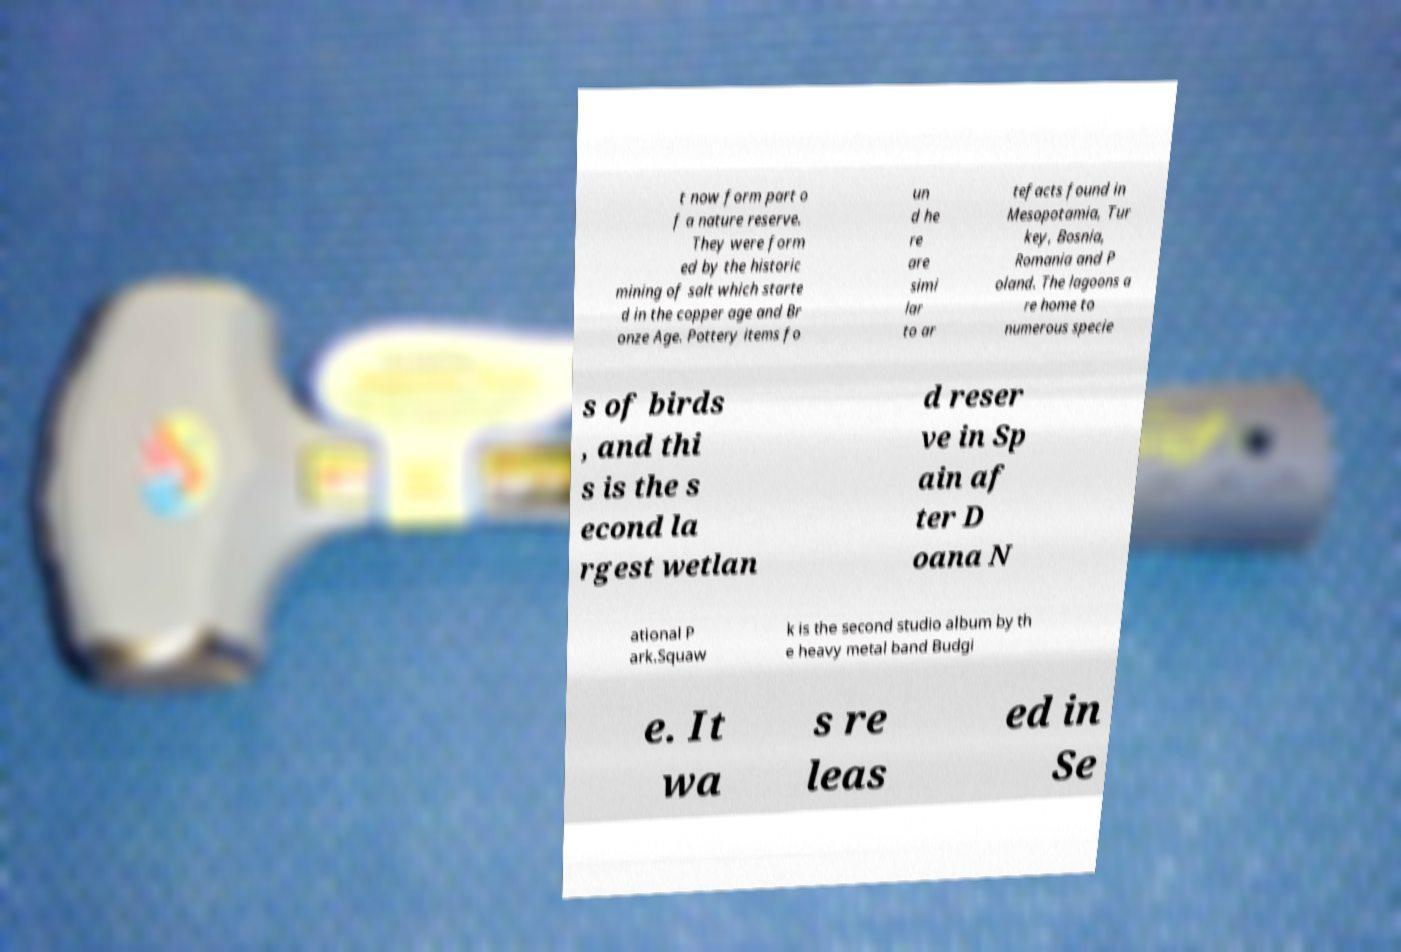Please identify and transcribe the text found in this image. t now form part o f a nature reserve. They were form ed by the historic mining of salt which starte d in the copper age and Br onze Age. Pottery items fo un d he re are simi lar to ar tefacts found in Mesopotamia, Tur key, Bosnia, Romania and P oland. The lagoons a re home to numerous specie s of birds , and thi s is the s econd la rgest wetlan d reser ve in Sp ain af ter D oana N ational P ark.Squaw k is the second studio album by th e heavy metal band Budgi e. It wa s re leas ed in Se 